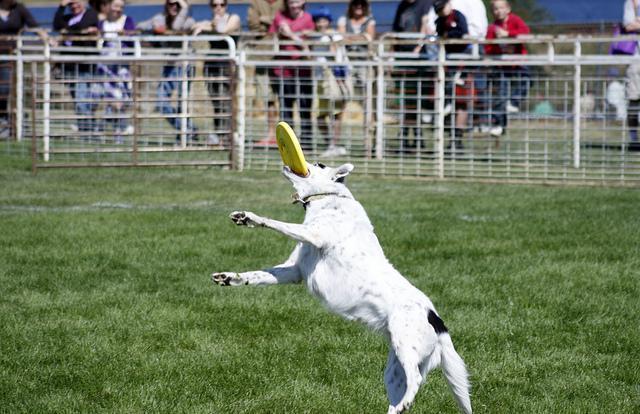How many people are there?
Give a very brief answer. 4. 